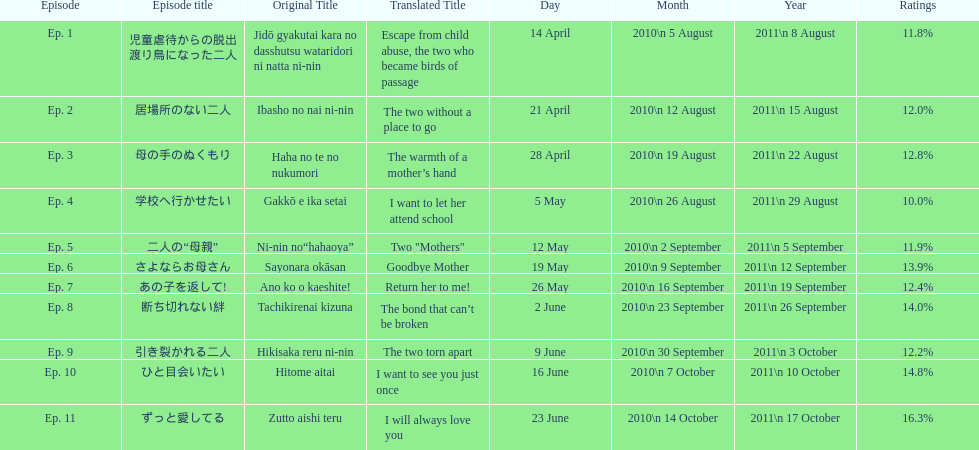How many episode total are there? 11. 